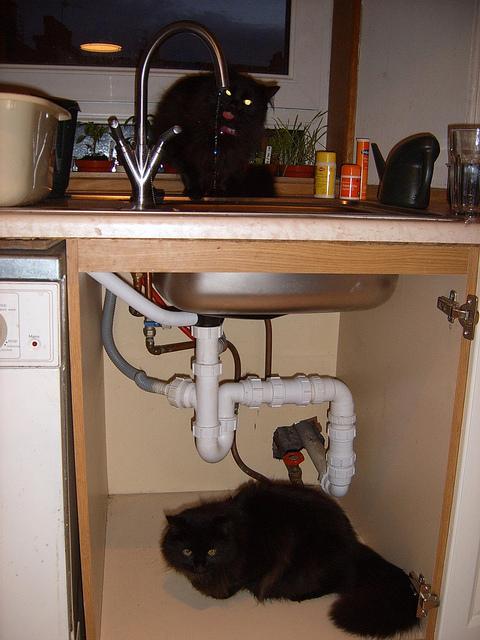What color is the shortest bottle?
Give a very brief answer. Orange. How many cats are in the picture?
Short answer required. 2. Does the cat look comfortable?
Quick response, please. Yes. 